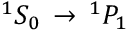<formula> <loc_0><loc_0><loc_500><loc_500>^ { 1 } S _ { 0 } \, \rightarrow \, ^ { 1 } P _ { 1 }</formula> 